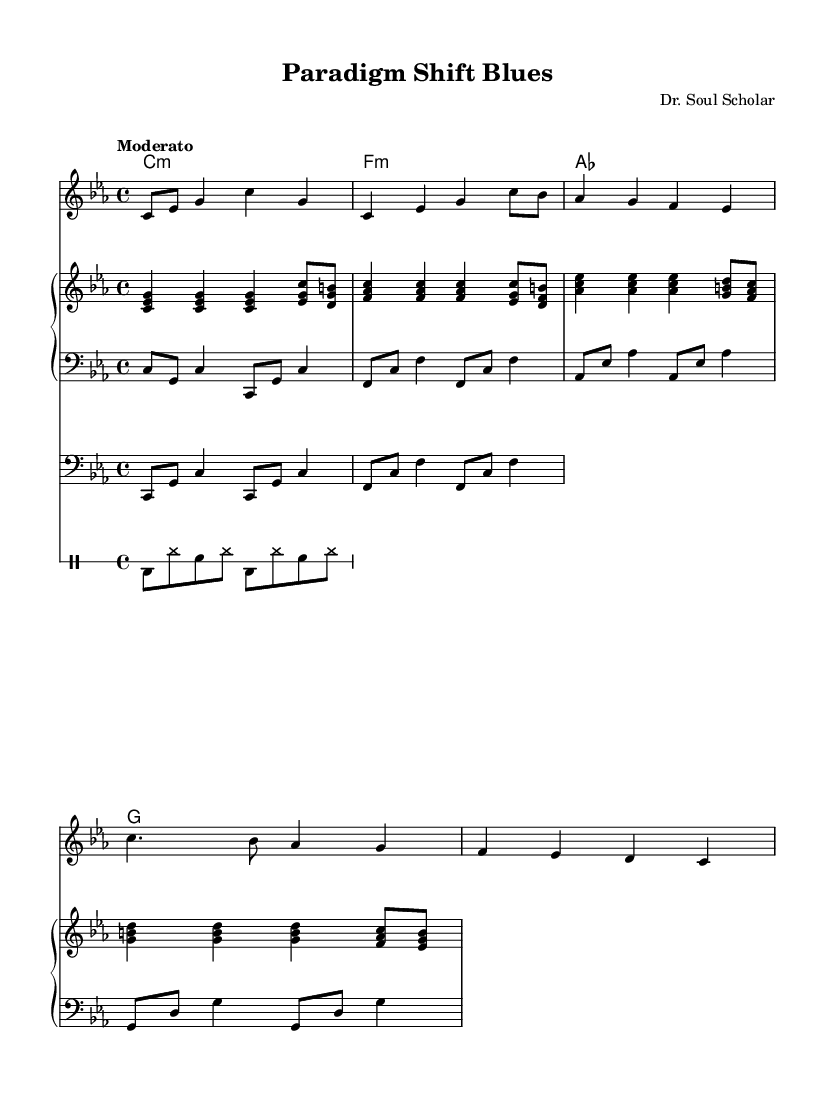What is the key signature of this piece? The key signature is C minor, which has three flats (B flat, E flat, A flat). This is indicated in the beginning of the sheet music.
Answer: C minor What is the time signature of this composition? The time signature is indicated as 4/4. This means there are four beats per measure and the quarter note receives one beat.
Answer: 4/4 What is the tempo marking for this piece? The tempo marking is "Moderato", which suggests a moderate speed for the performance, commonly interpreted as around 108-120 beats per minute.
Answer: Moderato How many measures are in the verse section? To determine this, we count the number of distinct measures in the verse part of the melody, which contains four measures.
Answer: Four What is the chord used in the chorus? The chord played in the chorus is B flat major, which is indicated in the chord mode section of the sheet music.
Answer: B flat Which intellectual movement is referenced in the lyrics of the verse? The verse references Structuralism, an intellectual movement influential during the 1960s, indicating its contribution to discussions in R&B lyrics.
Answer: Structuralism What is the function of the drum patterns in this piece? The drum patterns provide a rhythmic foundation and contribute to the overall groove, which is a crucial element in the rhythm and blues genre.
Answer: Groove 